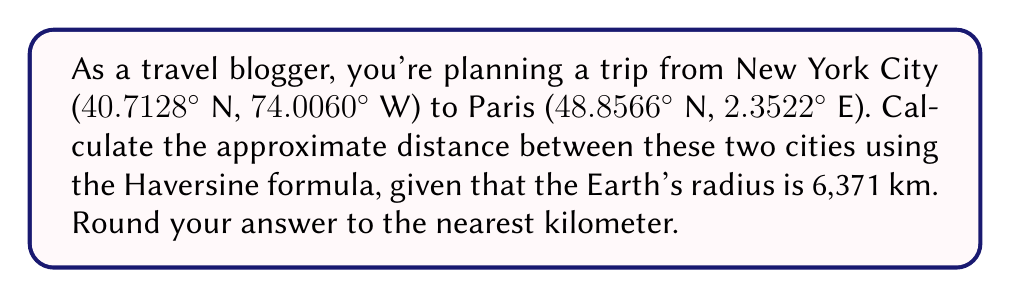Show me your answer to this math problem. To calculate the distance between two points on Earth using latitude and longitude, we'll use the Haversine formula:

1. Convert latitude and longitude to radians:
   $\text{lat}_1 = 40.7128° \cdot \frac{\pi}{180} = 0.7102$ rad
   $\text{lon}_1 = -74.0060° \cdot \frac{\pi}{180} = -1.2915$ rad
   $\text{lat}_2 = 48.8566° \cdot \frac{\pi}{180} = 0.8527$ rad
   $\text{lon}_2 = 2.3522° \cdot \frac{\pi}{180} = 0.0411$ rad

2. Calculate the differences:
   $\Delta\text{lat} = \text{lat}_2 - \text{lat}_1 = 0.1425$ rad
   $\Delta\text{lon} = \text{lon}_2 - \text{lon}_1 = 1.3326$ rad

3. Apply the Haversine formula:
   $$a = \sin^2(\frac{\Delta\text{lat}}{2}) + \cos(\text{lat}_1) \cdot \cos(\text{lat}_2) \cdot \sin^2(\frac{\Delta\text{lon}}{2})$$
   
   $$a = \sin^2(0.07125) + \cos(0.7102) \cdot \cos(0.8527) \cdot \sin^2(0.6663)$$
   
   $$a = 0.0051 + 0.7660 \cdot 0.6592 \cdot 0.3941 = 0.2049$$

4. Calculate the central angle:
   $$c = 2 \cdot \arctan2(\sqrt{a}, \sqrt{1-a})$$
   $$c = 2 \cdot \arctan2(\sqrt{0.2049}, \sqrt{0.7951}) = 0.9483$$

5. Calculate the distance:
   $$d = R \cdot c$$
   $$d = 6371 \cdot 0.9483 = 6041.77 \text{ km}$$

6. Round to the nearest kilometer:
   $d \approx 6042 \text{ km}$
Answer: 6042 km 